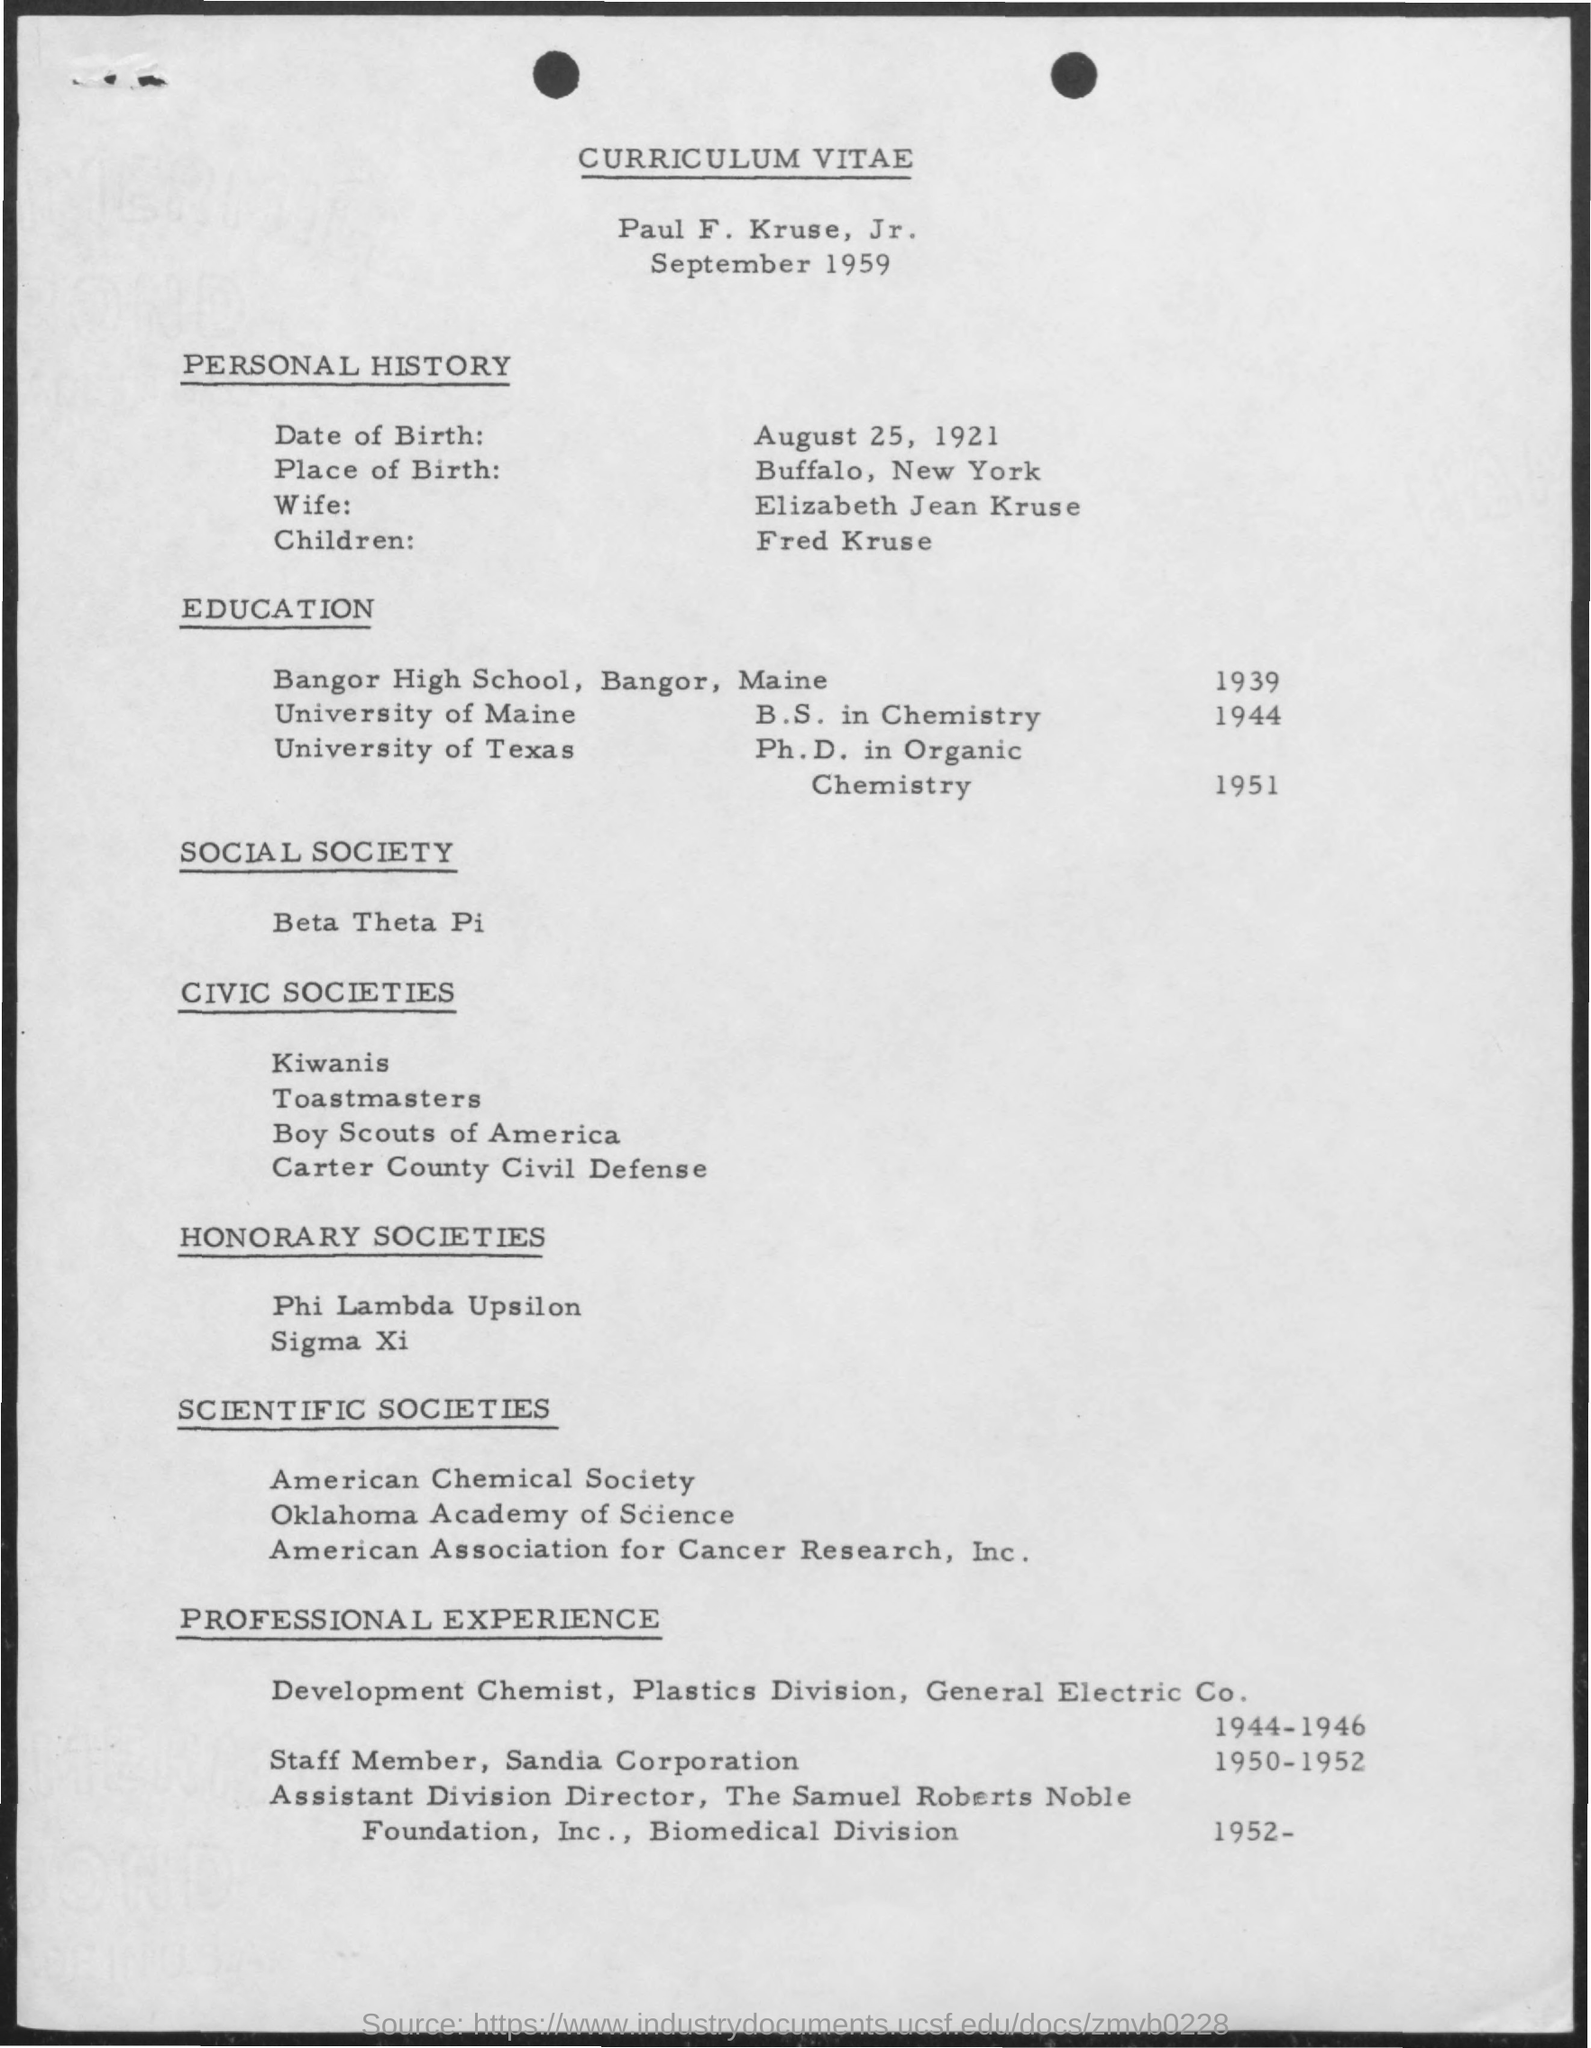Identify some key points in this picture. In 1951, he completed his Ph.D. His wife's name is Elizabeth Jean Kruse. The person completed their Ph.D. at the University of Texas. 